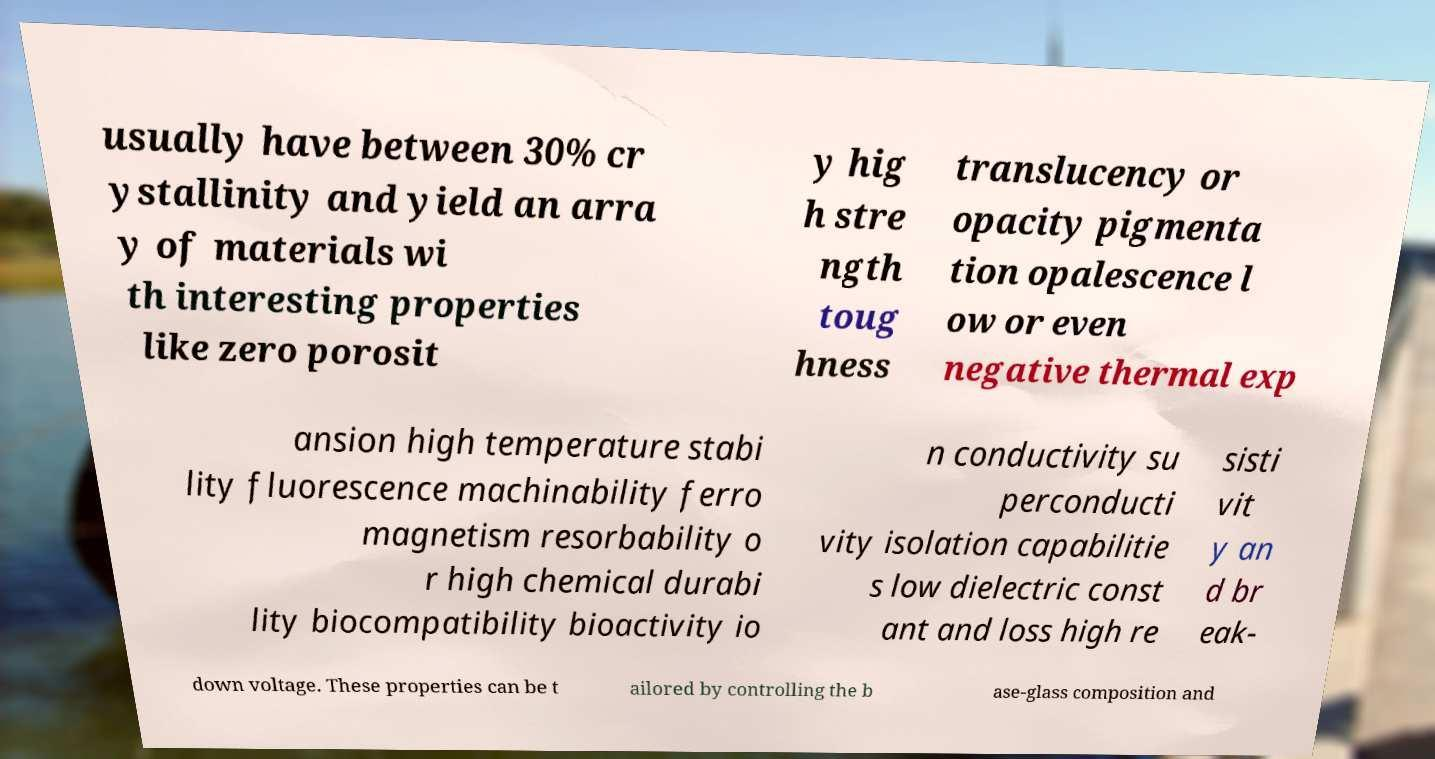For documentation purposes, I need the text within this image transcribed. Could you provide that? usually have between 30% cr ystallinity and yield an arra y of materials wi th interesting properties like zero porosit y hig h stre ngth toug hness translucency or opacity pigmenta tion opalescence l ow or even negative thermal exp ansion high temperature stabi lity fluorescence machinability ferro magnetism resorbability o r high chemical durabi lity biocompatibility bioactivity io n conductivity su perconducti vity isolation capabilitie s low dielectric const ant and loss high re sisti vit y an d br eak- down voltage. These properties can be t ailored by controlling the b ase-glass composition and 